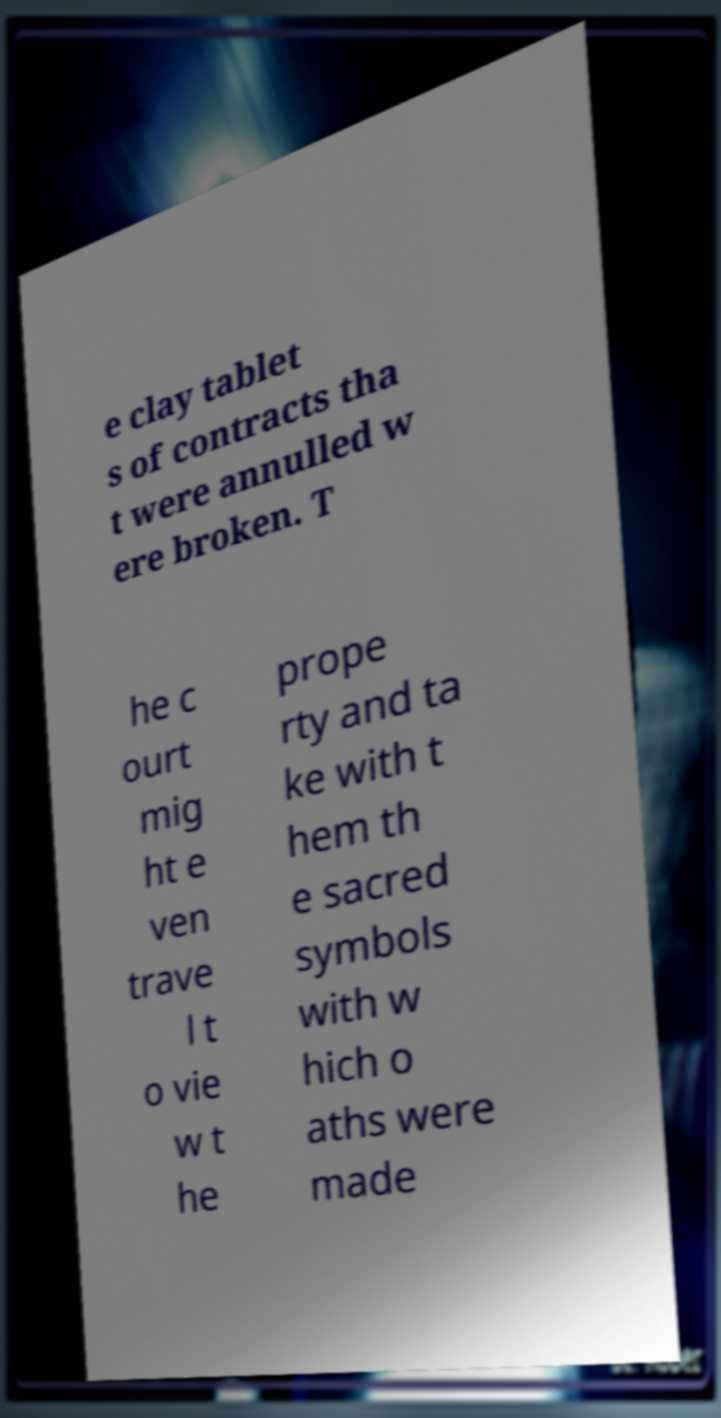I need the written content from this picture converted into text. Can you do that? e clay tablet s of contracts tha t were annulled w ere broken. T he c ourt mig ht e ven trave l t o vie w t he prope rty and ta ke with t hem th e sacred symbols with w hich o aths were made 